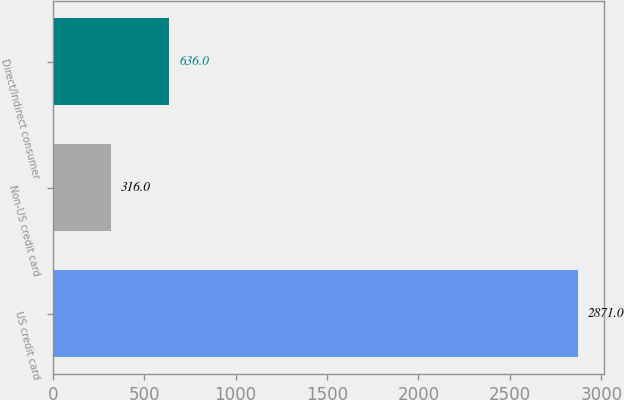Convert chart. <chart><loc_0><loc_0><loc_500><loc_500><bar_chart><fcel>US credit card<fcel>Non-US credit card<fcel>Direct/Indirect consumer<nl><fcel>2871<fcel>316<fcel>636<nl></chart> 